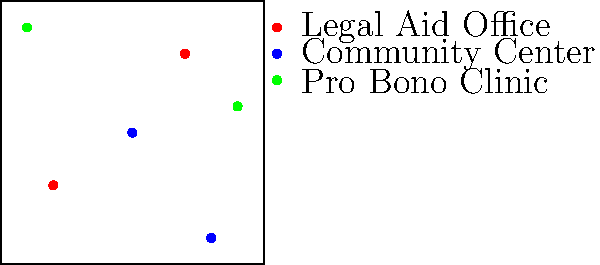Based on the map of legal resources in the city, how many Pro Bono Clinics are available for those seeking assistance with racial profiling cases? To answer this question, we need to follow these steps:

1. Identify the symbol for Pro Bono Clinics on the map:
   According to the legend, Pro Bono Clinics are represented by green dots.

2. Count the number of green dots on the map:
   - There is one green dot in the upper left quadrant of the map.
   - There is another green dot in the right side of the map, slightly above the center.

3. Sum up the total number of Pro Bono Clinics:
   There are 2 green dots in total on the map.

Therefore, there are 2 Pro Bono Clinics available for those seeking assistance with racial profiling cases in this city.
Answer: 2 